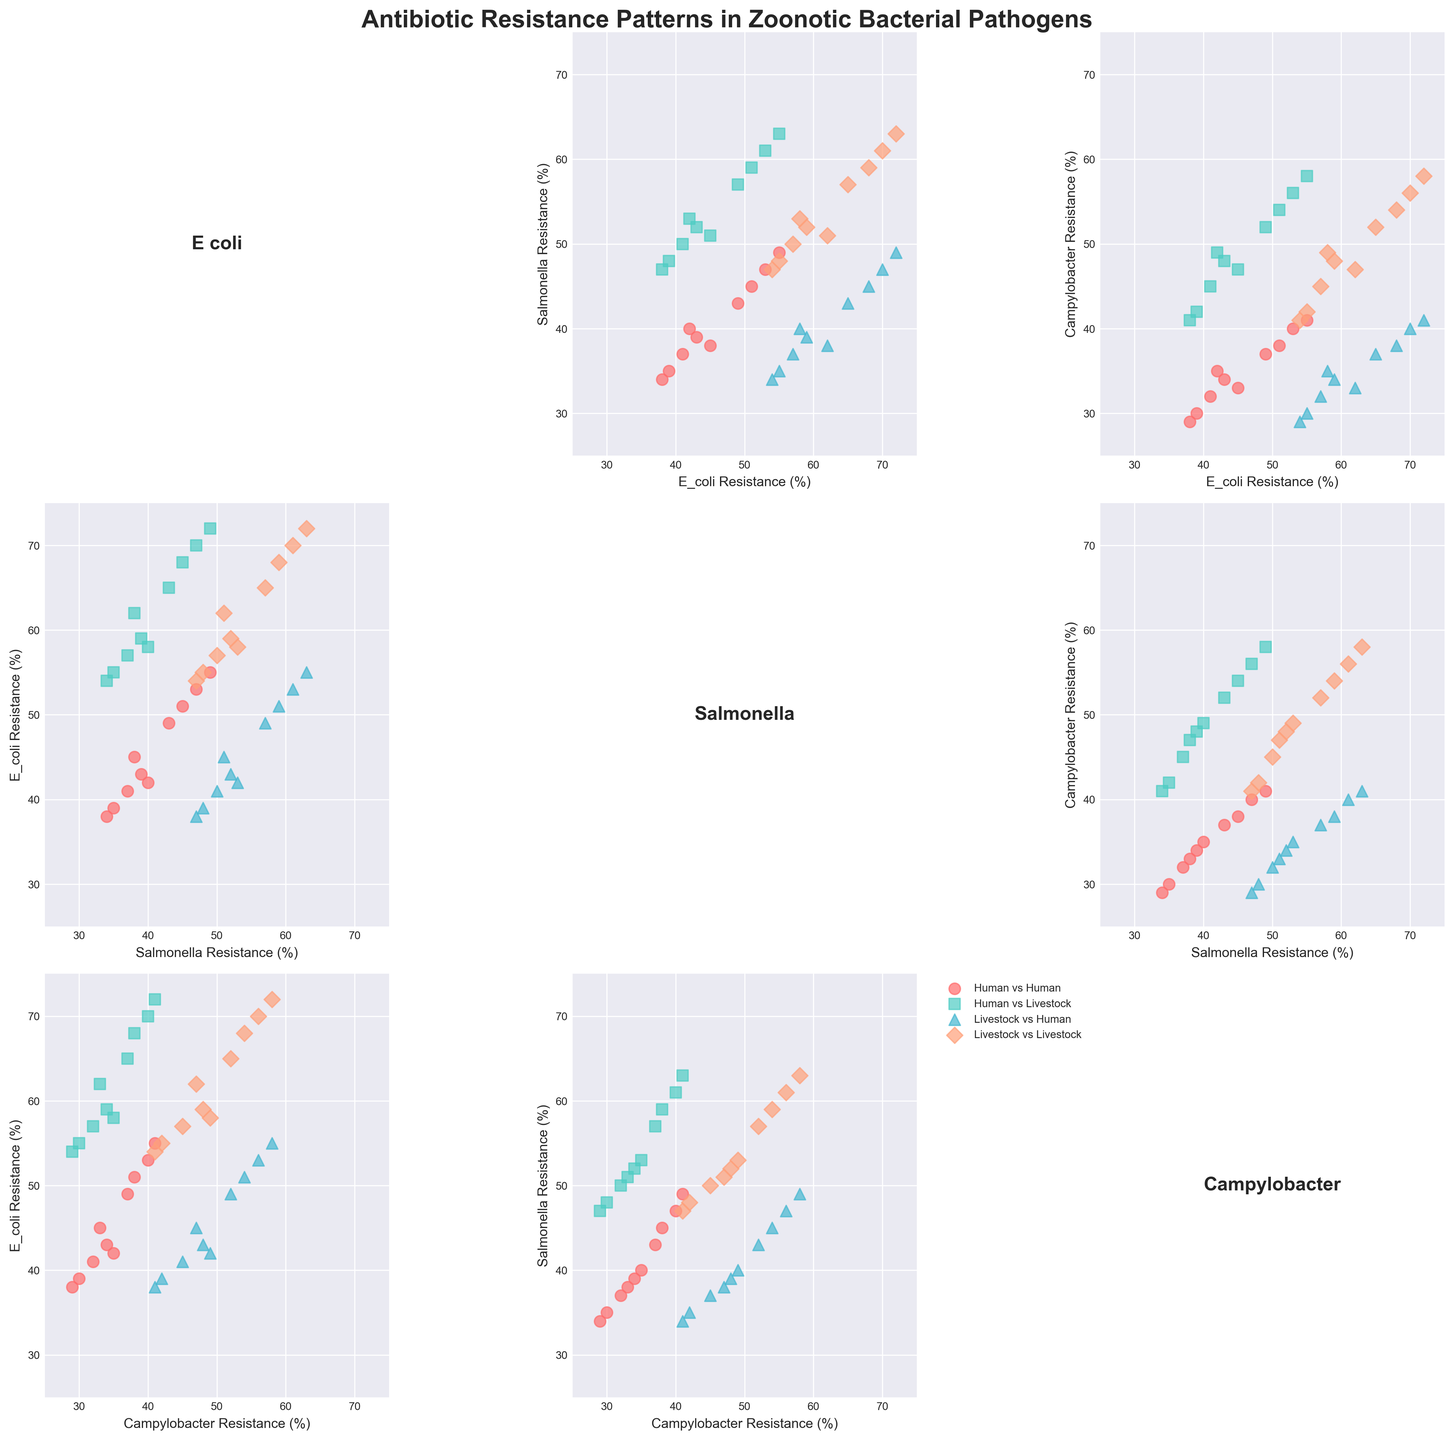Which country has the highest antibiotic resistance in E. coli isolated from livestock? By looking at the scatterplot points for E. coli in livestock, you can identify the country with the highest resistance located at the upper end of the y-axis for the E. coli Livestock plot.
Answer: India How does the resistance pattern of Salmonella differ between humans and livestock in the UK? Analyze the scatter points for Salmonella Human and Salmonella Livestock specifically for the UK, compare their positions on the axis.
Answer: Higher in livestock than in humans What's the range of antibiotic resistance for Campylobacter in humans? Find the lowest and highest values of Campylobacter Human data points across the plot and calculate the difference.
Answer: 29-41% Is there a stronger correlation between antibiotic resistance of Salmonella and E. coli in humans or in livestock? Assess the scatterplots comparing Salmonella Human vs. E. coli Human and Salmonella Livestock vs. E. coli Livestock and check which one shows a denser clustering along a trend line.
Answer: Humans Which pathogen shows the most variability in resistance between humans and livestock in China? Compare the distances between the points for each pathogen (E. coli, Salmonella, Campylobacter) between human and livestock sources for China on their respective scatter plots.
Answer: E. coli In which country is the difference in resistance of Campylobacter between humans and livestock the smallest? By checking the scatter points for Campylobacter Human vs. Campylobacter Livestock and measuring the vertical distance for each country, identify the one with the smallest gap.
Answer: Japan 